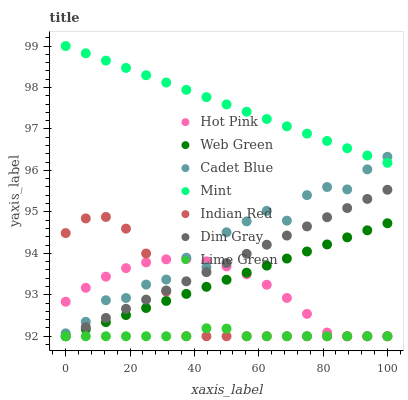Does Lime Green have the minimum area under the curve?
Answer yes or no. Yes. Does Mint have the maximum area under the curve?
Answer yes or no. Yes. Does Hot Pink have the minimum area under the curve?
Answer yes or no. No. Does Hot Pink have the maximum area under the curve?
Answer yes or no. No. Is Web Green the smoothest?
Answer yes or no. Yes. Is Cadet Blue the roughest?
Answer yes or no. Yes. Is Lime Green the smoothest?
Answer yes or no. No. Is Lime Green the roughest?
Answer yes or no. No. Does Lime Green have the lowest value?
Answer yes or no. Yes. Does Mint have the lowest value?
Answer yes or no. No. Does Mint have the highest value?
Answer yes or no. Yes. Does Hot Pink have the highest value?
Answer yes or no. No. Is Lime Green less than Cadet Blue?
Answer yes or no. Yes. Is Mint greater than Web Green?
Answer yes or no. Yes. Does Indian Red intersect Cadet Blue?
Answer yes or no. Yes. Is Indian Red less than Cadet Blue?
Answer yes or no. No. Is Indian Red greater than Cadet Blue?
Answer yes or no. No. Does Lime Green intersect Cadet Blue?
Answer yes or no. No. 